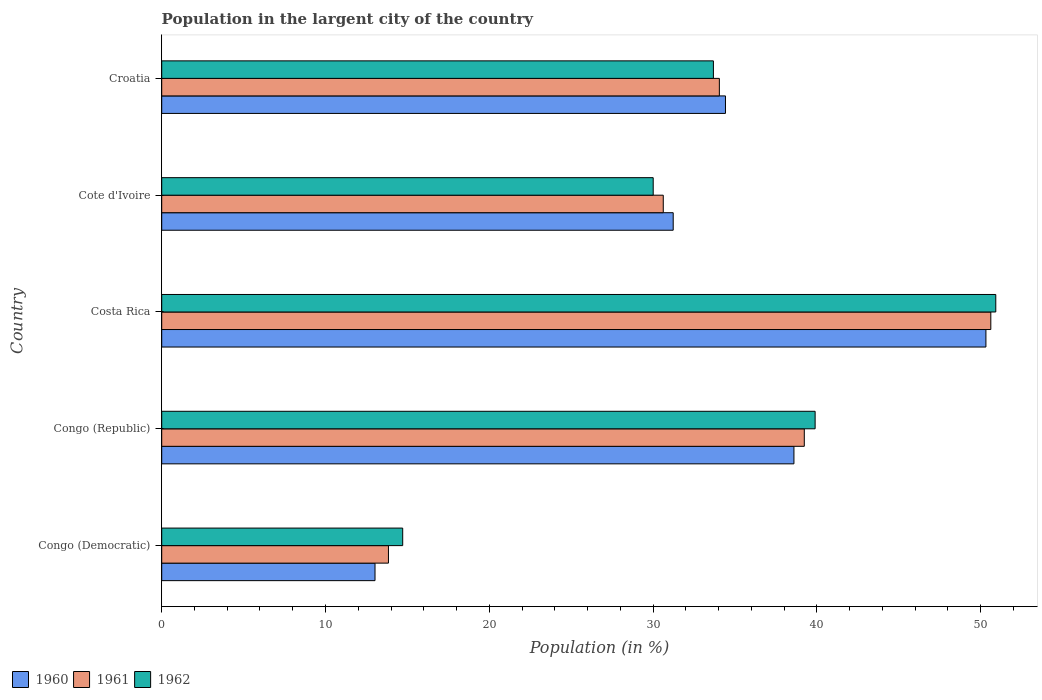Are the number of bars per tick equal to the number of legend labels?
Keep it short and to the point. Yes. Are the number of bars on each tick of the Y-axis equal?
Provide a succinct answer. Yes. How many bars are there on the 3rd tick from the top?
Give a very brief answer. 3. How many bars are there on the 5th tick from the bottom?
Offer a terse response. 3. What is the percentage of population in the largent city in 1960 in Costa Rica?
Offer a terse response. 50.32. Across all countries, what is the maximum percentage of population in the largent city in 1960?
Your answer should be very brief. 50.32. Across all countries, what is the minimum percentage of population in the largent city in 1962?
Provide a short and direct response. 14.71. In which country was the percentage of population in the largent city in 1962 minimum?
Make the answer very short. Congo (Democratic). What is the total percentage of population in the largent city in 1962 in the graph?
Your response must be concise. 169.23. What is the difference between the percentage of population in the largent city in 1961 in Cote d'Ivoire and that in Croatia?
Make the answer very short. -3.43. What is the difference between the percentage of population in the largent city in 1962 in Congo (Republic) and the percentage of population in the largent city in 1960 in Congo (Democratic)?
Keep it short and to the point. 26.87. What is the average percentage of population in the largent city in 1961 per country?
Provide a short and direct response. 33.68. What is the difference between the percentage of population in the largent city in 1960 and percentage of population in the largent city in 1962 in Congo (Democratic)?
Ensure brevity in your answer.  -1.69. In how many countries, is the percentage of population in the largent city in 1962 greater than 38 %?
Offer a very short reply. 2. What is the ratio of the percentage of population in the largent city in 1962 in Costa Rica to that in Croatia?
Keep it short and to the point. 1.51. What is the difference between the highest and the second highest percentage of population in the largent city in 1960?
Your answer should be compact. 11.72. What is the difference between the highest and the lowest percentage of population in the largent city in 1962?
Give a very brief answer. 36.21. In how many countries, is the percentage of population in the largent city in 1960 greater than the average percentage of population in the largent city in 1960 taken over all countries?
Provide a short and direct response. 3. Is the sum of the percentage of population in the largent city in 1960 in Costa Rica and Cote d'Ivoire greater than the maximum percentage of population in the largent city in 1962 across all countries?
Your answer should be compact. Yes. What does the 2nd bar from the bottom in Cote d'Ivoire represents?
Provide a succinct answer. 1961. Is it the case that in every country, the sum of the percentage of population in the largent city in 1961 and percentage of population in the largent city in 1960 is greater than the percentage of population in the largent city in 1962?
Offer a terse response. Yes. How many bars are there?
Ensure brevity in your answer.  15. Are all the bars in the graph horizontal?
Give a very brief answer. Yes. How many countries are there in the graph?
Keep it short and to the point. 5. What is the difference between two consecutive major ticks on the X-axis?
Provide a short and direct response. 10. Are the values on the major ticks of X-axis written in scientific E-notation?
Give a very brief answer. No. Where does the legend appear in the graph?
Your answer should be very brief. Bottom left. How are the legend labels stacked?
Make the answer very short. Horizontal. What is the title of the graph?
Give a very brief answer. Population in the largent city of the country. What is the label or title of the X-axis?
Give a very brief answer. Population (in %). What is the Population (in %) of 1960 in Congo (Democratic)?
Offer a terse response. 13.02. What is the Population (in %) in 1961 in Congo (Democratic)?
Keep it short and to the point. 13.84. What is the Population (in %) of 1962 in Congo (Democratic)?
Keep it short and to the point. 14.71. What is the Population (in %) of 1960 in Congo (Republic)?
Ensure brevity in your answer.  38.6. What is the Population (in %) in 1961 in Congo (Republic)?
Make the answer very short. 39.23. What is the Population (in %) of 1962 in Congo (Republic)?
Ensure brevity in your answer.  39.9. What is the Population (in %) of 1960 in Costa Rica?
Provide a short and direct response. 50.32. What is the Population (in %) of 1961 in Costa Rica?
Offer a very short reply. 50.62. What is the Population (in %) in 1962 in Costa Rica?
Provide a short and direct response. 50.93. What is the Population (in %) in 1960 in Cote d'Ivoire?
Your response must be concise. 31.23. What is the Population (in %) of 1961 in Cote d'Ivoire?
Your response must be concise. 30.62. What is the Population (in %) in 1962 in Cote d'Ivoire?
Ensure brevity in your answer.  30.01. What is the Population (in %) in 1960 in Croatia?
Keep it short and to the point. 34.42. What is the Population (in %) in 1961 in Croatia?
Your answer should be very brief. 34.05. What is the Population (in %) in 1962 in Croatia?
Offer a very short reply. 33.69. Across all countries, what is the maximum Population (in %) of 1960?
Give a very brief answer. 50.32. Across all countries, what is the maximum Population (in %) of 1961?
Provide a succinct answer. 50.62. Across all countries, what is the maximum Population (in %) in 1962?
Your answer should be compact. 50.93. Across all countries, what is the minimum Population (in %) in 1960?
Your answer should be compact. 13.02. Across all countries, what is the minimum Population (in %) of 1961?
Make the answer very short. 13.84. Across all countries, what is the minimum Population (in %) in 1962?
Your answer should be very brief. 14.71. What is the total Population (in %) of 1960 in the graph?
Your answer should be compact. 167.6. What is the total Population (in %) in 1961 in the graph?
Keep it short and to the point. 168.38. What is the total Population (in %) of 1962 in the graph?
Your answer should be very brief. 169.23. What is the difference between the Population (in %) of 1960 in Congo (Democratic) and that in Congo (Republic)?
Give a very brief answer. -25.58. What is the difference between the Population (in %) in 1961 in Congo (Democratic) and that in Congo (Republic)?
Your response must be concise. -25.39. What is the difference between the Population (in %) of 1962 in Congo (Democratic) and that in Congo (Republic)?
Make the answer very short. -25.18. What is the difference between the Population (in %) in 1960 in Congo (Democratic) and that in Costa Rica?
Give a very brief answer. -37.3. What is the difference between the Population (in %) in 1961 in Congo (Democratic) and that in Costa Rica?
Provide a succinct answer. -36.78. What is the difference between the Population (in %) in 1962 in Congo (Democratic) and that in Costa Rica?
Provide a succinct answer. -36.21. What is the difference between the Population (in %) of 1960 in Congo (Democratic) and that in Cote d'Ivoire?
Provide a short and direct response. -18.21. What is the difference between the Population (in %) in 1961 in Congo (Democratic) and that in Cote d'Ivoire?
Ensure brevity in your answer.  -16.78. What is the difference between the Population (in %) of 1962 in Congo (Democratic) and that in Cote d'Ivoire?
Offer a very short reply. -15.3. What is the difference between the Population (in %) of 1960 in Congo (Democratic) and that in Croatia?
Your answer should be compact. -21.4. What is the difference between the Population (in %) in 1961 in Congo (Democratic) and that in Croatia?
Ensure brevity in your answer.  -20.2. What is the difference between the Population (in %) of 1962 in Congo (Democratic) and that in Croatia?
Your answer should be very brief. -18.97. What is the difference between the Population (in %) of 1960 in Congo (Republic) and that in Costa Rica?
Offer a terse response. -11.72. What is the difference between the Population (in %) of 1961 in Congo (Republic) and that in Costa Rica?
Ensure brevity in your answer.  -11.39. What is the difference between the Population (in %) of 1962 in Congo (Republic) and that in Costa Rica?
Offer a very short reply. -11.03. What is the difference between the Population (in %) in 1960 in Congo (Republic) and that in Cote d'Ivoire?
Offer a very short reply. 7.37. What is the difference between the Population (in %) in 1961 in Congo (Republic) and that in Cote d'Ivoire?
Provide a succinct answer. 8.61. What is the difference between the Population (in %) of 1962 in Congo (Republic) and that in Cote d'Ivoire?
Make the answer very short. 9.89. What is the difference between the Population (in %) of 1960 in Congo (Republic) and that in Croatia?
Your answer should be compact. 4.18. What is the difference between the Population (in %) in 1961 in Congo (Republic) and that in Croatia?
Make the answer very short. 5.19. What is the difference between the Population (in %) of 1962 in Congo (Republic) and that in Croatia?
Your answer should be compact. 6.21. What is the difference between the Population (in %) of 1960 in Costa Rica and that in Cote d'Ivoire?
Offer a very short reply. 19.09. What is the difference between the Population (in %) of 1961 in Costa Rica and that in Cote d'Ivoire?
Your answer should be very brief. 20. What is the difference between the Population (in %) of 1962 in Costa Rica and that in Cote d'Ivoire?
Make the answer very short. 20.92. What is the difference between the Population (in %) of 1960 in Costa Rica and that in Croatia?
Provide a short and direct response. 15.9. What is the difference between the Population (in %) of 1961 in Costa Rica and that in Croatia?
Your response must be concise. 16.57. What is the difference between the Population (in %) of 1962 in Costa Rica and that in Croatia?
Keep it short and to the point. 17.24. What is the difference between the Population (in %) of 1960 in Cote d'Ivoire and that in Croatia?
Provide a succinct answer. -3.19. What is the difference between the Population (in %) of 1961 in Cote d'Ivoire and that in Croatia?
Make the answer very short. -3.43. What is the difference between the Population (in %) in 1962 in Cote d'Ivoire and that in Croatia?
Give a very brief answer. -3.68. What is the difference between the Population (in %) in 1960 in Congo (Democratic) and the Population (in %) in 1961 in Congo (Republic)?
Provide a short and direct response. -26.21. What is the difference between the Population (in %) of 1960 in Congo (Democratic) and the Population (in %) of 1962 in Congo (Republic)?
Give a very brief answer. -26.87. What is the difference between the Population (in %) of 1961 in Congo (Democratic) and the Population (in %) of 1962 in Congo (Republic)?
Your answer should be very brief. -26.05. What is the difference between the Population (in %) of 1960 in Congo (Democratic) and the Population (in %) of 1961 in Costa Rica?
Your answer should be compact. -37.6. What is the difference between the Population (in %) of 1960 in Congo (Democratic) and the Population (in %) of 1962 in Costa Rica?
Ensure brevity in your answer.  -37.9. What is the difference between the Population (in %) of 1961 in Congo (Democratic) and the Population (in %) of 1962 in Costa Rica?
Provide a short and direct response. -37.08. What is the difference between the Population (in %) in 1960 in Congo (Democratic) and the Population (in %) in 1961 in Cote d'Ivoire?
Your answer should be very brief. -17.6. What is the difference between the Population (in %) in 1960 in Congo (Democratic) and the Population (in %) in 1962 in Cote d'Ivoire?
Your response must be concise. -16.99. What is the difference between the Population (in %) of 1961 in Congo (Democratic) and the Population (in %) of 1962 in Cote d'Ivoire?
Keep it short and to the point. -16.16. What is the difference between the Population (in %) in 1960 in Congo (Democratic) and the Population (in %) in 1961 in Croatia?
Your answer should be compact. -21.03. What is the difference between the Population (in %) in 1960 in Congo (Democratic) and the Population (in %) in 1962 in Croatia?
Ensure brevity in your answer.  -20.66. What is the difference between the Population (in %) in 1961 in Congo (Democratic) and the Population (in %) in 1962 in Croatia?
Keep it short and to the point. -19.84. What is the difference between the Population (in %) in 1960 in Congo (Republic) and the Population (in %) in 1961 in Costa Rica?
Ensure brevity in your answer.  -12.02. What is the difference between the Population (in %) in 1960 in Congo (Republic) and the Population (in %) in 1962 in Costa Rica?
Your answer should be very brief. -12.32. What is the difference between the Population (in %) of 1961 in Congo (Republic) and the Population (in %) of 1962 in Costa Rica?
Make the answer very short. -11.69. What is the difference between the Population (in %) in 1960 in Congo (Republic) and the Population (in %) in 1961 in Cote d'Ivoire?
Ensure brevity in your answer.  7.98. What is the difference between the Population (in %) in 1960 in Congo (Republic) and the Population (in %) in 1962 in Cote d'Ivoire?
Make the answer very short. 8.59. What is the difference between the Population (in %) of 1961 in Congo (Republic) and the Population (in %) of 1962 in Cote d'Ivoire?
Provide a short and direct response. 9.23. What is the difference between the Population (in %) of 1960 in Congo (Republic) and the Population (in %) of 1961 in Croatia?
Your response must be concise. 4.55. What is the difference between the Population (in %) in 1960 in Congo (Republic) and the Population (in %) in 1962 in Croatia?
Keep it short and to the point. 4.92. What is the difference between the Population (in %) in 1961 in Congo (Republic) and the Population (in %) in 1962 in Croatia?
Provide a short and direct response. 5.55. What is the difference between the Population (in %) of 1960 in Costa Rica and the Population (in %) of 1961 in Cote d'Ivoire?
Offer a very short reply. 19.7. What is the difference between the Population (in %) in 1960 in Costa Rica and the Population (in %) in 1962 in Cote d'Ivoire?
Your answer should be very brief. 20.32. What is the difference between the Population (in %) of 1961 in Costa Rica and the Population (in %) of 1962 in Cote d'Ivoire?
Provide a short and direct response. 20.61. What is the difference between the Population (in %) in 1960 in Costa Rica and the Population (in %) in 1961 in Croatia?
Keep it short and to the point. 16.28. What is the difference between the Population (in %) of 1960 in Costa Rica and the Population (in %) of 1962 in Croatia?
Provide a short and direct response. 16.64. What is the difference between the Population (in %) of 1961 in Costa Rica and the Population (in %) of 1962 in Croatia?
Make the answer very short. 16.94. What is the difference between the Population (in %) of 1960 in Cote d'Ivoire and the Population (in %) of 1961 in Croatia?
Provide a succinct answer. -2.82. What is the difference between the Population (in %) in 1960 in Cote d'Ivoire and the Population (in %) in 1962 in Croatia?
Keep it short and to the point. -2.45. What is the difference between the Population (in %) in 1961 in Cote d'Ivoire and the Population (in %) in 1962 in Croatia?
Offer a very short reply. -3.06. What is the average Population (in %) in 1960 per country?
Your answer should be compact. 33.52. What is the average Population (in %) in 1961 per country?
Provide a succinct answer. 33.67. What is the average Population (in %) in 1962 per country?
Make the answer very short. 33.85. What is the difference between the Population (in %) of 1960 and Population (in %) of 1961 in Congo (Democratic)?
Provide a succinct answer. -0.82. What is the difference between the Population (in %) in 1960 and Population (in %) in 1962 in Congo (Democratic)?
Offer a very short reply. -1.69. What is the difference between the Population (in %) in 1961 and Population (in %) in 1962 in Congo (Democratic)?
Offer a very short reply. -0.87. What is the difference between the Population (in %) of 1960 and Population (in %) of 1961 in Congo (Republic)?
Offer a very short reply. -0.63. What is the difference between the Population (in %) of 1960 and Population (in %) of 1962 in Congo (Republic)?
Your answer should be compact. -1.29. What is the difference between the Population (in %) in 1961 and Population (in %) in 1962 in Congo (Republic)?
Keep it short and to the point. -0.66. What is the difference between the Population (in %) of 1960 and Population (in %) of 1961 in Costa Rica?
Give a very brief answer. -0.3. What is the difference between the Population (in %) of 1960 and Population (in %) of 1962 in Costa Rica?
Your answer should be compact. -0.6. What is the difference between the Population (in %) in 1961 and Population (in %) in 1962 in Costa Rica?
Offer a very short reply. -0.3. What is the difference between the Population (in %) of 1960 and Population (in %) of 1961 in Cote d'Ivoire?
Make the answer very short. 0.61. What is the difference between the Population (in %) of 1960 and Population (in %) of 1962 in Cote d'Ivoire?
Your answer should be very brief. 1.22. What is the difference between the Population (in %) of 1961 and Population (in %) of 1962 in Cote d'Ivoire?
Give a very brief answer. 0.61. What is the difference between the Population (in %) of 1960 and Population (in %) of 1961 in Croatia?
Give a very brief answer. 0.37. What is the difference between the Population (in %) of 1960 and Population (in %) of 1962 in Croatia?
Make the answer very short. 0.74. What is the difference between the Population (in %) of 1961 and Population (in %) of 1962 in Croatia?
Ensure brevity in your answer.  0.36. What is the ratio of the Population (in %) in 1960 in Congo (Democratic) to that in Congo (Republic)?
Provide a succinct answer. 0.34. What is the ratio of the Population (in %) of 1961 in Congo (Democratic) to that in Congo (Republic)?
Offer a terse response. 0.35. What is the ratio of the Population (in %) in 1962 in Congo (Democratic) to that in Congo (Republic)?
Keep it short and to the point. 0.37. What is the ratio of the Population (in %) of 1960 in Congo (Democratic) to that in Costa Rica?
Your response must be concise. 0.26. What is the ratio of the Population (in %) in 1961 in Congo (Democratic) to that in Costa Rica?
Make the answer very short. 0.27. What is the ratio of the Population (in %) in 1962 in Congo (Democratic) to that in Costa Rica?
Provide a succinct answer. 0.29. What is the ratio of the Population (in %) of 1960 in Congo (Democratic) to that in Cote d'Ivoire?
Provide a succinct answer. 0.42. What is the ratio of the Population (in %) in 1961 in Congo (Democratic) to that in Cote d'Ivoire?
Ensure brevity in your answer.  0.45. What is the ratio of the Population (in %) of 1962 in Congo (Democratic) to that in Cote d'Ivoire?
Give a very brief answer. 0.49. What is the ratio of the Population (in %) in 1960 in Congo (Democratic) to that in Croatia?
Ensure brevity in your answer.  0.38. What is the ratio of the Population (in %) of 1961 in Congo (Democratic) to that in Croatia?
Keep it short and to the point. 0.41. What is the ratio of the Population (in %) in 1962 in Congo (Democratic) to that in Croatia?
Provide a short and direct response. 0.44. What is the ratio of the Population (in %) in 1960 in Congo (Republic) to that in Costa Rica?
Make the answer very short. 0.77. What is the ratio of the Population (in %) of 1961 in Congo (Republic) to that in Costa Rica?
Give a very brief answer. 0.78. What is the ratio of the Population (in %) of 1962 in Congo (Republic) to that in Costa Rica?
Your answer should be very brief. 0.78. What is the ratio of the Population (in %) in 1960 in Congo (Republic) to that in Cote d'Ivoire?
Offer a very short reply. 1.24. What is the ratio of the Population (in %) in 1961 in Congo (Republic) to that in Cote d'Ivoire?
Your answer should be compact. 1.28. What is the ratio of the Population (in %) in 1962 in Congo (Republic) to that in Cote d'Ivoire?
Ensure brevity in your answer.  1.33. What is the ratio of the Population (in %) in 1960 in Congo (Republic) to that in Croatia?
Provide a succinct answer. 1.12. What is the ratio of the Population (in %) in 1961 in Congo (Republic) to that in Croatia?
Give a very brief answer. 1.15. What is the ratio of the Population (in %) of 1962 in Congo (Republic) to that in Croatia?
Your answer should be very brief. 1.18. What is the ratio of the Population (in %) in 1960 in Costa Rica to that in Cote d'Ivoire?
Provide a short and direct response. 1.61. What is the ratio of the Population (in %) in 1961 in Costa Rica to that in Cote d'Ivoire?
Your answer should be very brief. 1.65. What is the ratio of the Population (in %) in 1962 in Costa Rica to that in Cote d'Ivoire?
Ensure brevity in your answer.  1.7. What is the ratio of the Population (in %) in 1960 in Costa Rica to that in Croatia?
Provide a succinct answer. 1.46. What is the ratio of the Population (in %) in 1961 in Costa Rica to that in Croatia?
Offer a very short reply. 1.49. What is the ratio of the Population (in %) of 1962 in Costa Rica to that in Croatia?
Give a very brief answer. 1.51. What is the ratio of the Population (in %) in 1960 in Cote d'Ivoire to that in Croatia?
Your answer should be compact. 0.91. What is the ratio of the Population (in %) in 1961 in Cote d'Ivoire to that in Croatia?
Your answer should be compact. 0.9. What is the ratio of the Population (in %) in 1962 in Cote d'Ivoire to that in Croatia?
Give a very brief answer. 0.89. What is the difference between the highest and the second highest Population (in %) in 1960?
Offer a very short reply. 11.72. What is the difference between the highest and the second highest Population (in %) in 1961?
Offer a terse response. 11.39. What is the difference between the highest and the second highest Population (in %) in 1962?
Offer a terse response. 11.03. What is the difference between the highest and the lowest Population (in %) of 1960?
Your response must be concise. 37.3. What is the difference between the highest and the lowest Population (in %) of 1961?
Offer a very short reply. 36.78. What is the difference between the highest and the lowest Population (in %) of 1962?
Offer a very short reply. 36.21. 